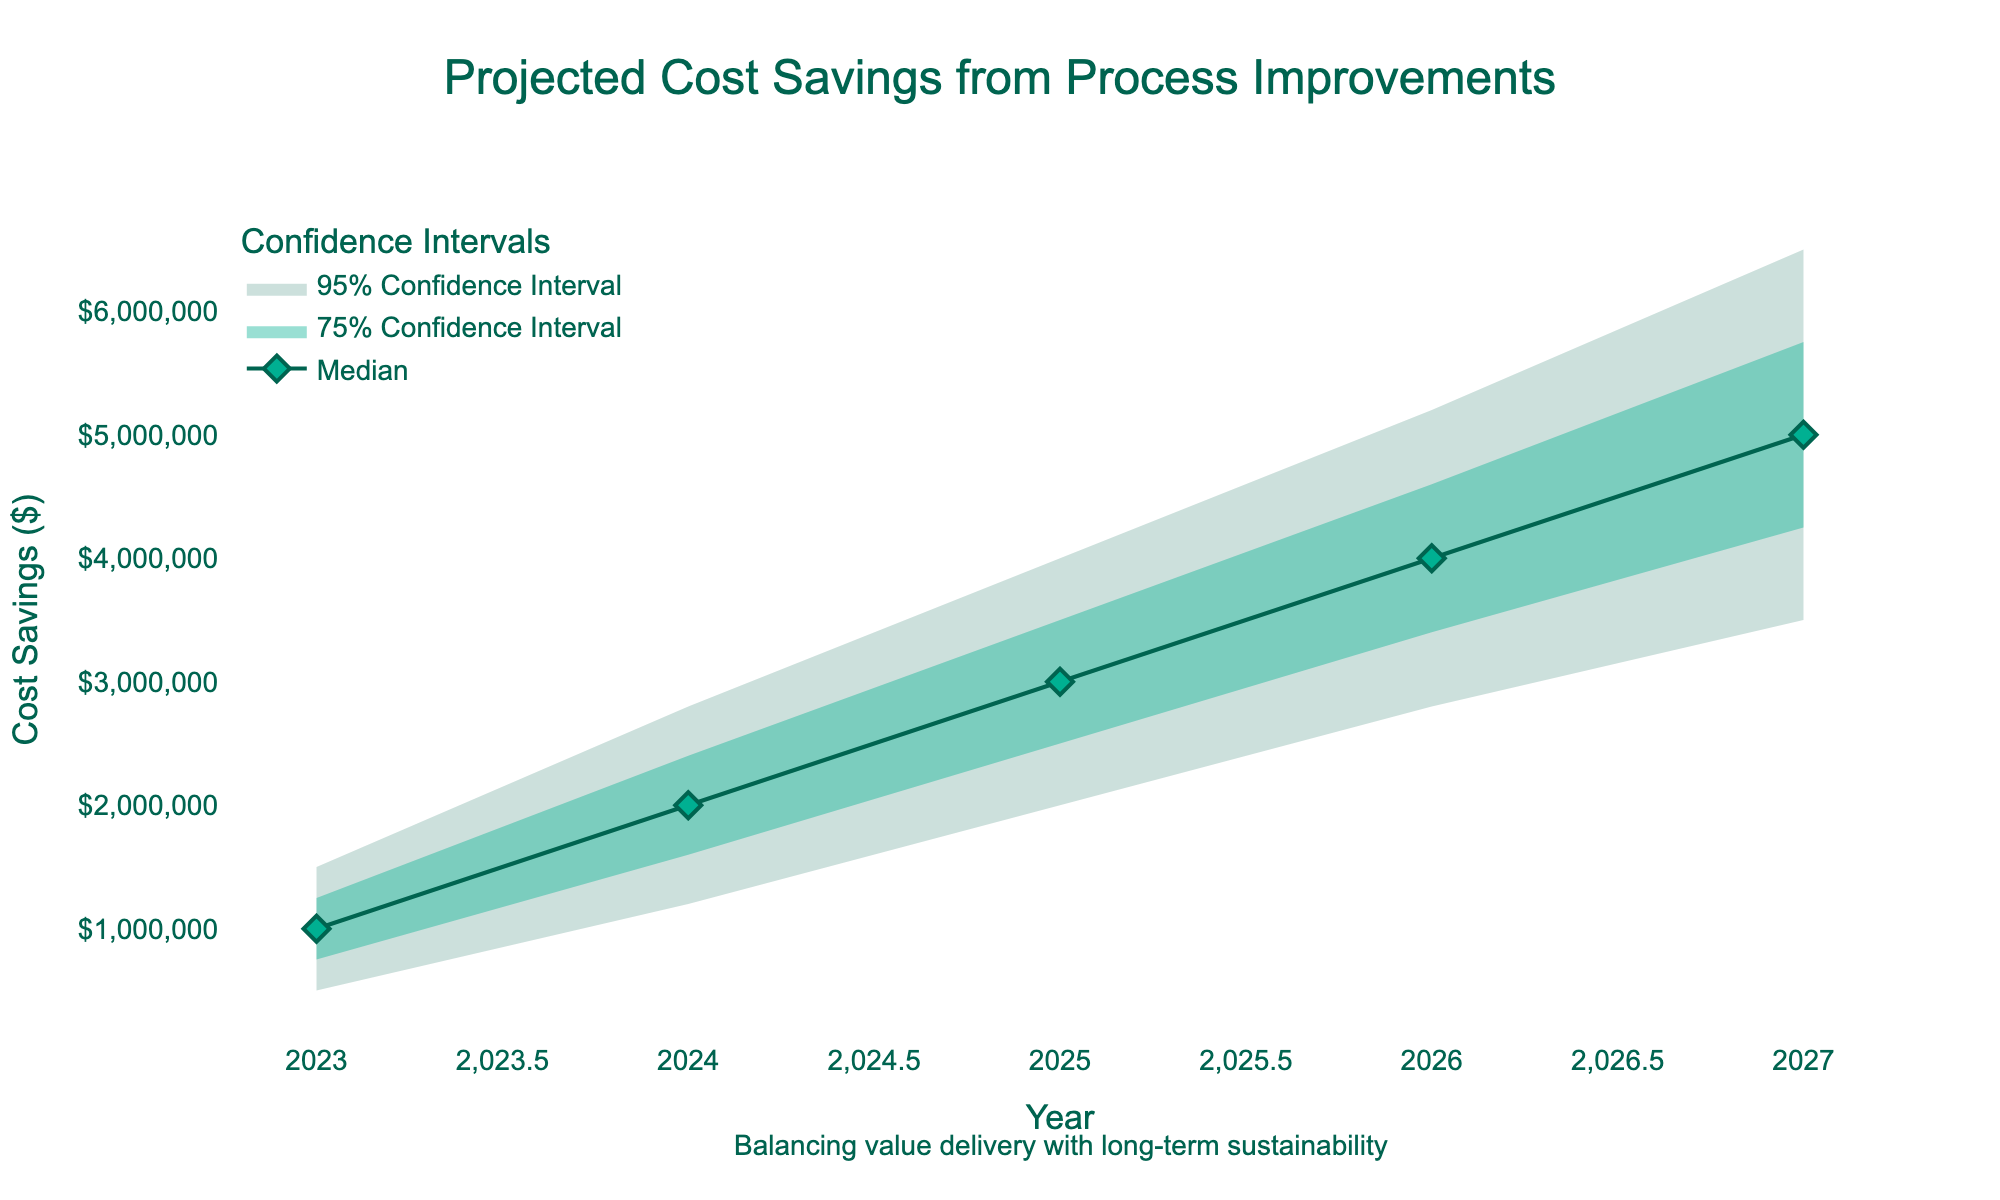What is the title of the chart? The title is usually placed at the top of a chart. In this case, it reads "Projected Cost Savings from Process Improvements."
Answer: Projected Cost Savings from Process Improvements What years are covered in this projection? The x-axis of the chart lists the years included in the data. Here, the years span from 2023 to 2027.
Answer: 2023 to 2027 What is the median projected cost savings for the year 2025? The median line represents the central value of the projection. By looking at the plot for the year 2025 on the median line, we see the value is $3,000,000.
Answer: $3,000,000 How wide is the 95% confidence interval for the year 2024? To find the width of the 95% confidence interval, subtract the lower bound from the upper bound. For 2024, the bounds are $1,200,000 and $2,800,000. Therefore, $2,800,000 - $1,200,000 = $1,600,000.
Answer: $1,600,000 Between which years does the cost saving projection see the highest increase in the median value? By examining the median line's values per year, we can trace where the increase is largest. The values are $1,000,000 (2023), $2,000,000 (2024), $3,000,000 (2025), $4,000,000 (2026), and $5,000,000 (2027). The biggest jump is between 2023 and 2024 at $1,000,000.
Answer: 2023 and 2024 What is the minimum value represented in the chart for the year 2027? The minimum value for any year corresponds to the lower bound of the 95% confidence interval on the chart. For 2027, that value is $3,500,000.
Answer: $3,500,000 Which year shows the maximum value in the 75% confidence interval? For the 75% confidence interval, we need the upper bound value for each year. The values are: $1,250,000 (2023), $2,400,000 (2024), $3,500,000 (2025), $4,600,000 (2026), and $5,750,000 (2027). The maximum is $5,750,000 in 2027.
Answer: 2027 What is the purpose of the annotation at the bottom of the chart? The annotation provides additional context or a message aligned with the chart's insights. Here, it reads, "Balancing value delivery with long-term sustainability."
Answer: Balancing value delivery with long-term sustainability Comparing the 75% and 95% confidence intervals, how do their widths change from 2023 to 2027? The widths of these intervals give an idea of data spread. For each year, compute the difference between high and low bounds of both intervals and compare. The 95% interval widens more significantly from 2023's $1,000,000 to 2027's $3,000,000, while the 75% interval widens from $500,000 to $2,250,000. Hence, both intervals increase, but the 95% interval increases more.
Answer: 95% widens more 